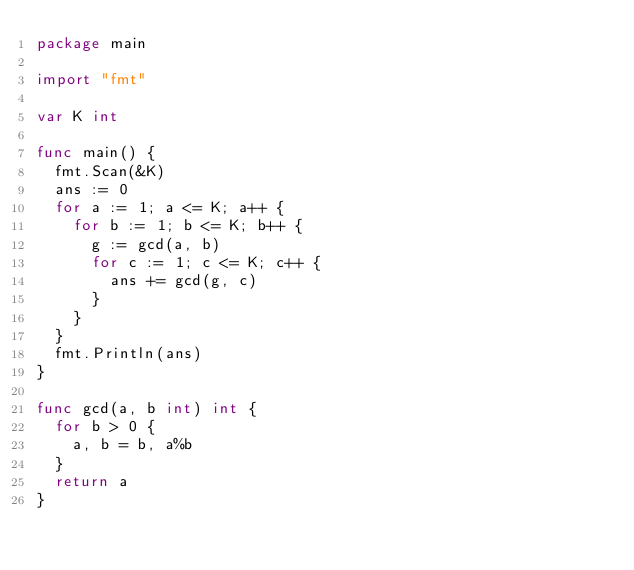<code> <loc_0><loc_0><loc_500><loc_500><_Go_>package main

import "fmt"

var K int

func main() {
	fmt.Scan(&K)
	ans := 0
	for a := 1; a <= K; a++ {
		for b := 1; b <= K; b++ {
			g := gcd(a, b)
			for c := 1; c <= K; c++ {
				ans += gcd(g, c)
			}
		}
	}
	fmt.Println(ans)
}

func gcd(a, b int) int {
	for b > 0 {
		a, b = b, a%b
	}
	return a
}
</code> 